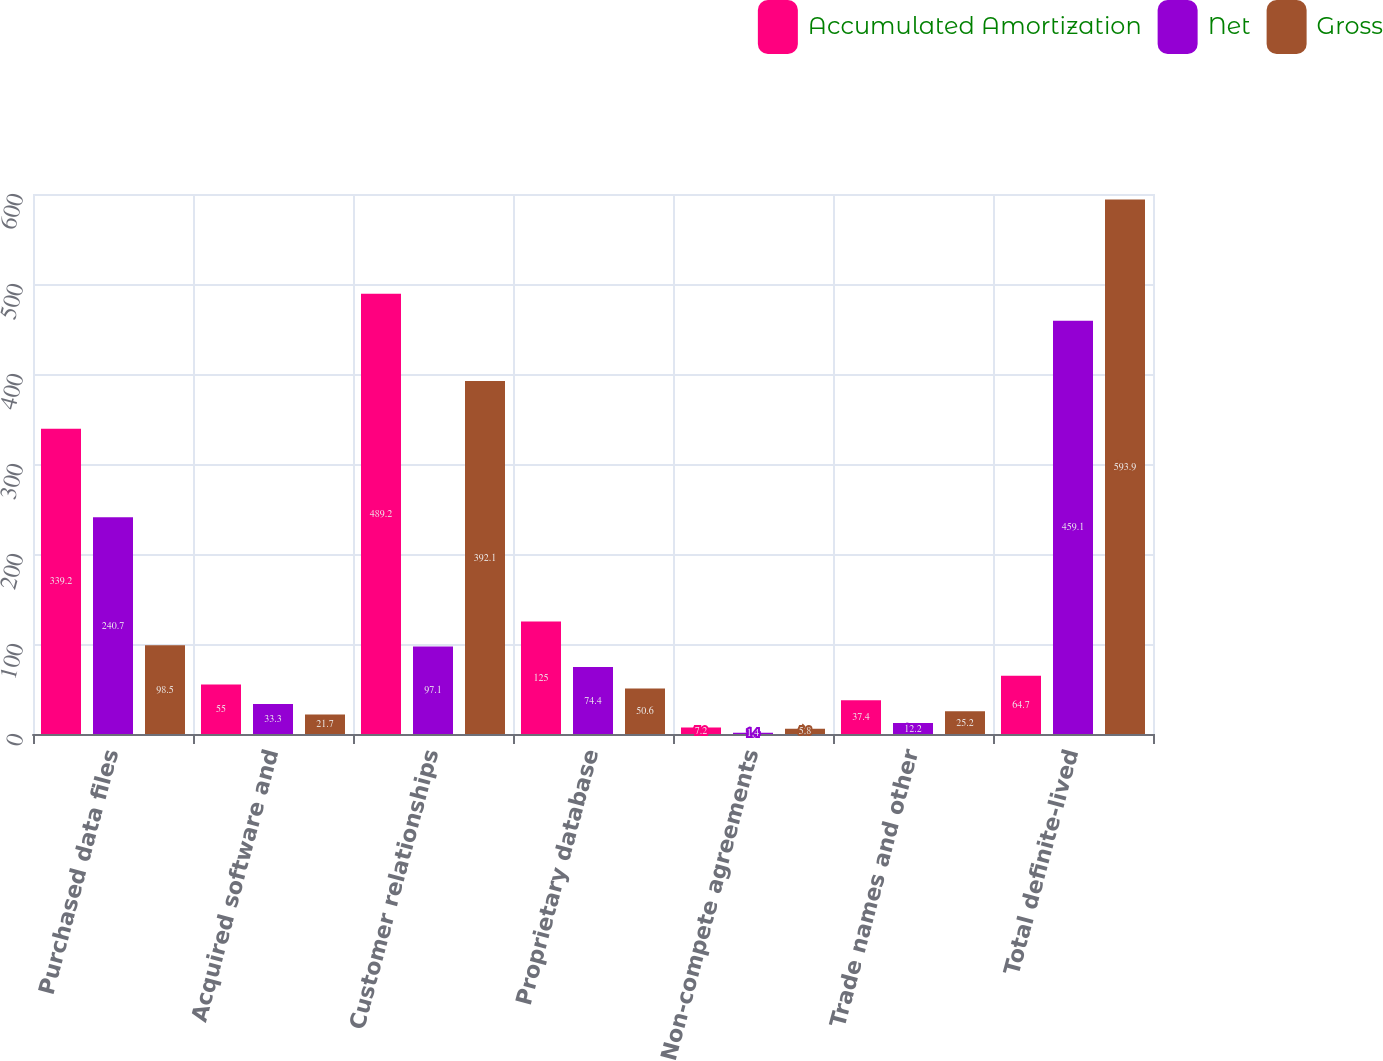<chart> <loc_0><loc_0><loc_500><loc_500><stacked_bar_chart><ecel><fcel>Purchased data files<fcel>Acquired software and<fcel>Customer relationships<fcel>Proprietary database<fcel>Non-compete agreements<fcel>Trade names and other<fcel>Total definite-lived<nl><fcel>Accumulated Amortization<fcel>339.2<fcel>55<fcel>489.2<fcel>125<fcel>7.2<fcel>37.4<fcel>64.7<nl><fcel>Net<fcel>240.7<fcel>33.3<fcel>97.1<fcel>74.4<fcel>1.4<fcel>12.2<fcel>459.1<nl><fcel>Gross<fcel>98.5<fcel>21.7<fcel>392.1<fcel>50.6<fcel>5.8<fcel>25.2<fcel>593.9<nl></chart> 